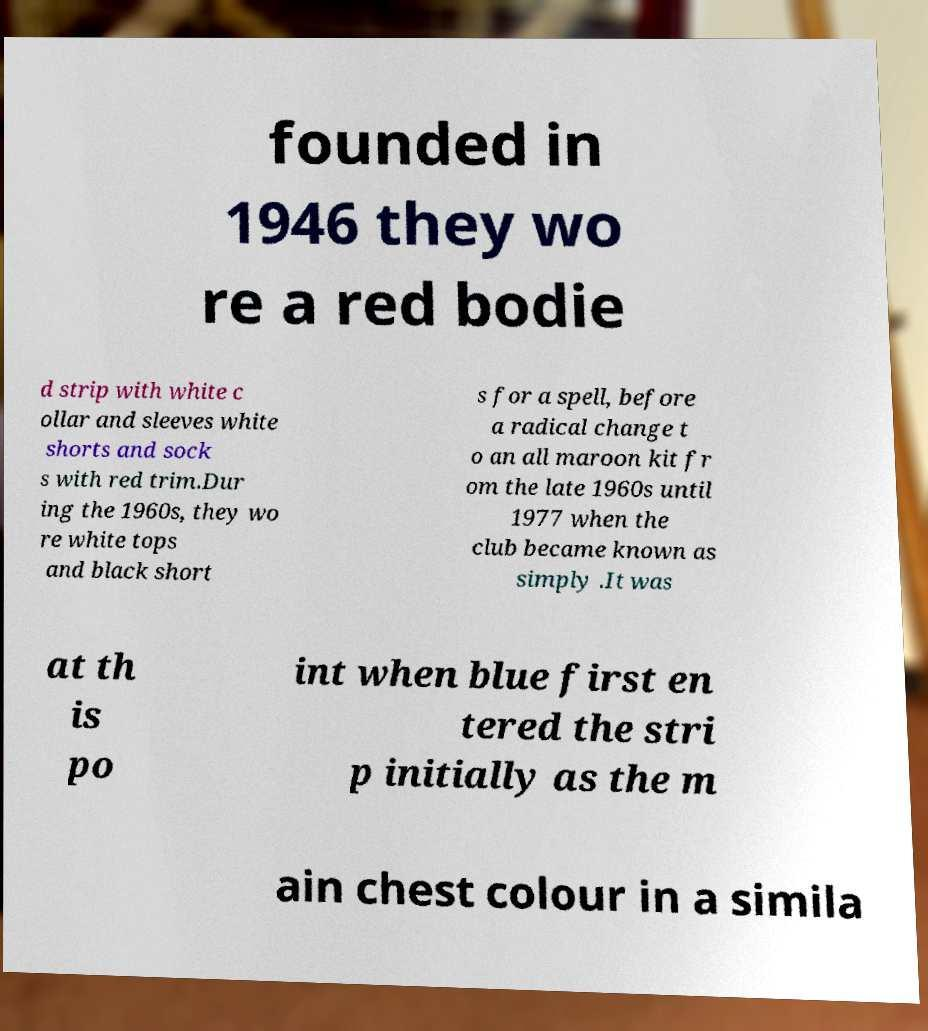Can you accurately transcribe the text from the provided image for me? founded in 1946 they wo re a red bodie d strip with white c ollar and sleeves white shorts and sock s with red trim.Dur ing the 1960s, they wo re white tops and black short s for a spell, before a radical change t o an all maroon kit fr om the late 1960s until 1977 when the club became known as simply .It was at th is po int when blue first en tered the stri p initially as the m ain chest colour in a simila 